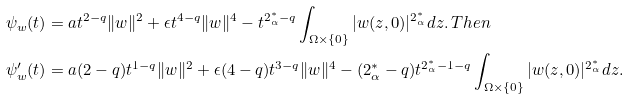Convert formula to latex. <formula><loc_0><loc_0><loc_500><loc_500>& \psi _ { w } ( t ) = a t ^ { 2 - q } \| w \| ^ { 2 } + \epsilon t ^ { 4 - q } \| w \| ^ { 4 } - t ^ { 2 ^ { * } _ { \alpha } - q } \int _ { \Omega \times \{ 0 \} } | w ( z , 0 ) | ^ { 2 ^ { * } _ { \alpha } } d z . \, T h e n \, \\ & \psi _ { w } ^ { \prime } ( t ) = a ( 2 - q ) t ^ { 1 - q } \| w \| ^ { 2 } + \epsilon ( 4 - q ) t ^ { 3 - q } \| w \| ^ { 4 } - ( 2 ^ { * } _ { \alpha } - q ) t ^ { 2 ^ { * } _ { \alpha } - 1 - q } \int _ { \Omega \times \{ 0 \} } | w ( z , 0 ) | ^ { 2 ^ { * } _ { \alpha } } d z .</formula> 